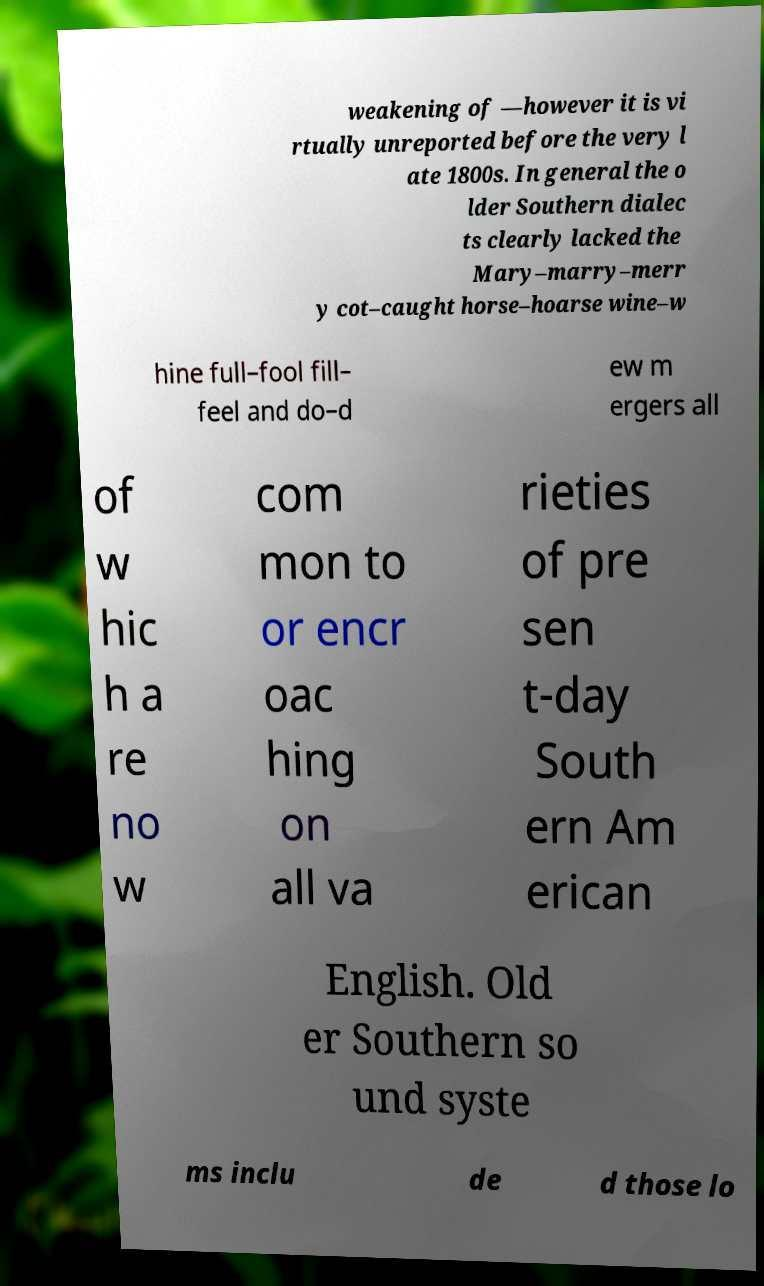Can you read and provide the text displayed in the image?This photo seems to have some interesting text. Can you extract and type it out for me? weakening of —however it is vi rtually unreported before the very l ate 1800s. In general the o lder Southern dialec ts clearly lacked the Mary–marry–merr y cot–caught horse–hoarse wine–w hine full–fool fill– feel and do–d ew m ergers all of w hic h a re no w com mon to or encr oac hing on all va rieties of pre sen t-day South ern Am erican English. Old er Southern so und syste ms inclu de d those lo 